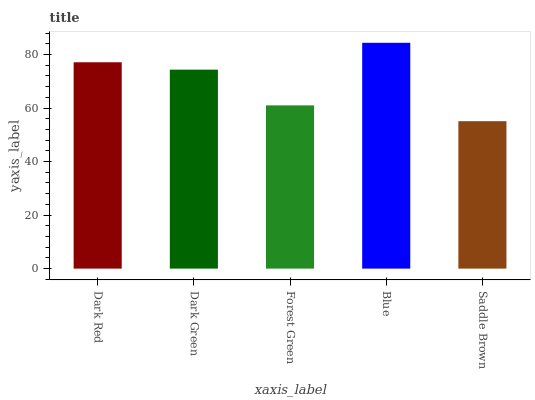Is Saddle Brown the minimum?
Answer yes or no. Yes. Is Blue the maximum?
Answer yes or no. Yes. Is Dark Green the minimum?
Answer yes or no. No. Is Dark Green the maximum?
Answer yes or no. No. Is Dark Red greater than Dark Green?
Answer yes or no. Yes. Is Dark Green less than Dark Red?
Answer yes or no. Yes. Is Dark Green greater than Dark Red?
Answer yes or no. No. Is Dark Red less than Dark Green?
Answer yes or no. No. Is Dark Green the high median?
Answer yes or no. Yes. Is Dark Green the low median?
Answer yes or no. Yes. Is Forest Green the high median?
Answer yes or no. No. Is Dark Red the low median?
Answer yes or no. No. 